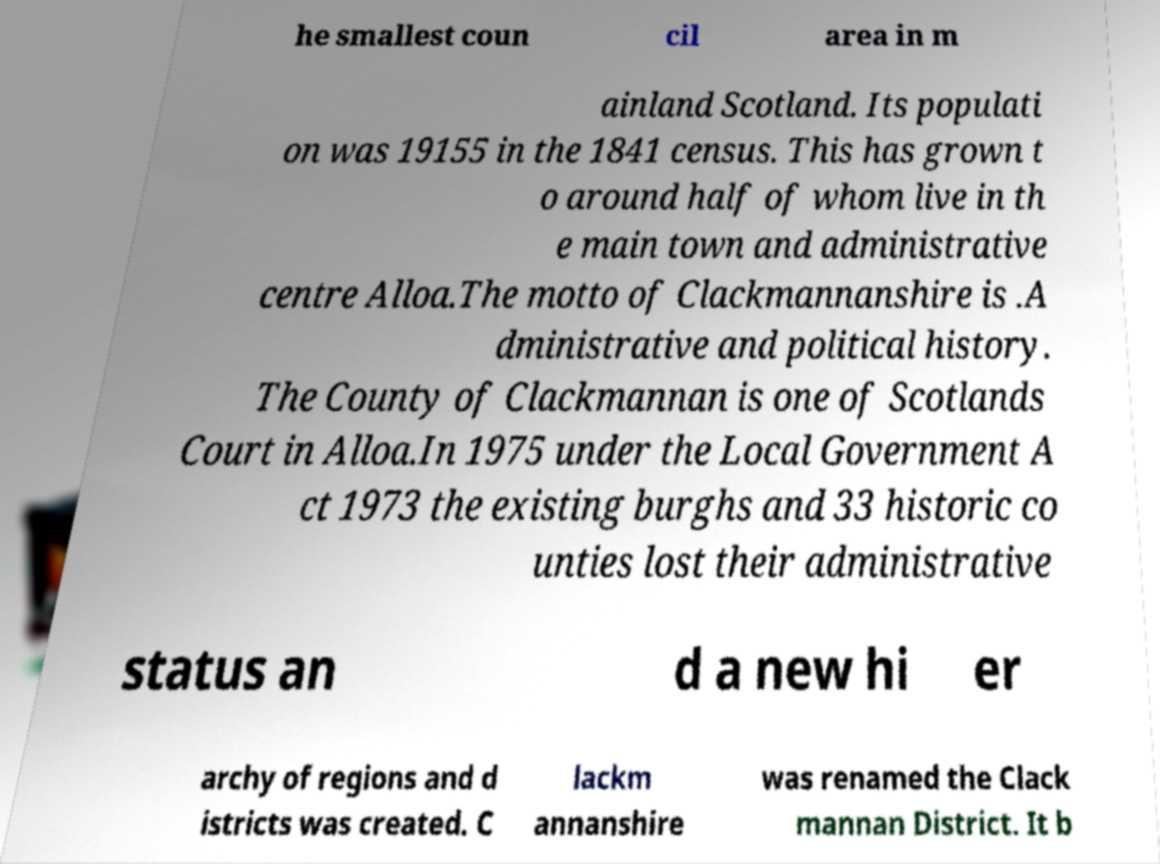Could you assist in decoding the text presented in this image and type it out clearly? he smallest coun cil area in m ainland Scotland. Its populati on was 19155 in the 1841 census. This has grown t o around half of whom live in th e main town and administrative centre Alloa.The motto of Clackmannanshire is .A dministrative and political history. The County of Clackmannan is one of Scotlands Court in Alloa.In 1975 under the Local Government A ct 1973 the existing burghs and 33 historic co unties lost their administrative status an d a new hi er archy of regions and d istricts was created. C lackm annanshire was renamed the Clack mannan District. It b 